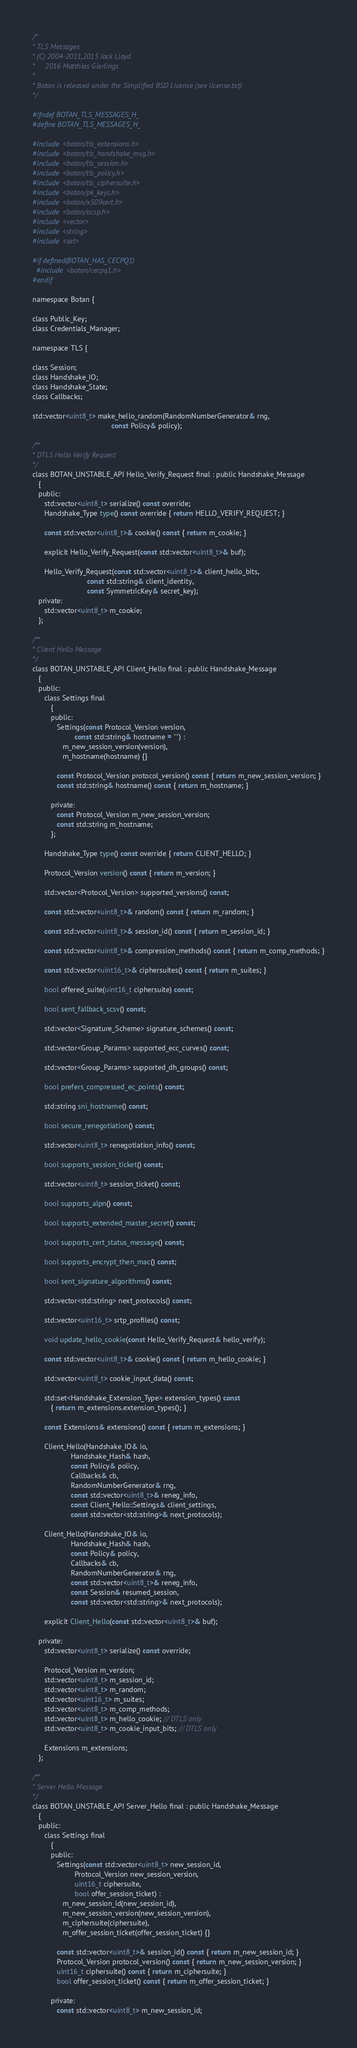<code> <loc_0><loc_0><loc_500><loc_500><_C_>/*
* TLS Messages
* (C) 2004-2011,2015 Jack Lloyd
*     2016 Matthias Gierlings
*
* Botan is released under the Simplified BSD License (see license.txt)
*/

#ifndef BOTAN_TLS_MESSAGES_H_
#define BOTAN_TLS_MESSAGES_H_

#include <botan/tls_extensions.h>
#include <botan/tls_handshake_msg.h>
#include <botan/tls_session.h>
#include <botan/tls_policy.h>
#include <botan/tls_ciphersuite.h>
#include <botan/pk_keys.h>
#include <botan/x509cert.h>
#include <botan/ocsp.h>
#include <vector>
#include <string>
#include <set>

#if defined(BOTAN_HAS_CECPQ1)
  #include <botan/cecpq1.h>
#endif

namespace Botan {

class Public_Key;
class Credentials_Manager;

namespace TLS {

class Session;
class Handshake_IO;
class Handshake_State;
class Callbacks;

std::vector<uint8_t> make_hello_random(RandomNumberGenerator& rng,
                                       const Policy& policy);

/**
* DTLS Hello Verify Request
*/
class BOTAN_UNSTABLE_API Hello_Verify_Request final : public Handshake_Message
   {
   public:
      std::vector<uint8_t> serialize() const override;
      Handshake_Type type() const override { return HELLO_VERIFY_REQUEST; }

      const std::vector<uint8_t>& cookie() const { return m_cookie; }

      explicit Hello_Verify_Request(const std::vector<uint8_t>& buf);

      Hello_Verify_Request(const std::vector<uint8_t>& client_hello_bits,
                           const std::string& client_identity,
                           const SymmetricKey& secret_key);
   private:
      std::vector<uint8_t> m_cookie;
   };

/**
* Client Hello Message
*/
class BOTAN_UNSTABLE_API Client_Hello final : public Handshake_Message
   {
   public:
      class Settings final
         {
         public:
            Settings(const Protocol_Version version,
                     const std::string& hostname = "") :
               m_new_session_version(version),
               m_hostname(hostname) {}

            const Protocol_Version protocol_version() const { return m_new_session_version; }
            const std::string& hostname() const { return m_hostname; }

         private:
            const Protocol_Version m_new_session_version;
            const std::string m_hostname;
         };

      Handshake_Type type() const override { return CLIENT_HELLO; }

      Protocol_Version version() const { return m_version; }

      std::vector<Protocol_Version> supported_versions() const;

      const std::vector<uint8_t>& random() const { return m_random; }

      const std::vector<uint8_t>& session_id() const { return m_session_id; }

      const std::vector<uint8_t>& compression_methods() const { return m_comp_methods; }

      const std::vector<uint16_t>& ciphersuites() const { return m_suites; }

      bool offered_suite(uint16_t ciphersuite) const;

      bool sent_fallback_scsv() const;

      std::vector<Signature_Scheme> signature_schemes() const;

      std::vector<Group_Params> supported_ecc_curves() const;

      std::vector<Group_Params> supported_dh_groups() const;

      bool prefers_compressed_ec_points() const;

      std::string sni_hostname() const;

      bool secure_renegotiation() const;

      std::vector<uint8_t> renegotiation_info() const;

      bool supports_session_ticket() const;

      std::vector<uint8_t> session_ticket() const;

      bool supports_alpn() const;

      bool supports_extended_master_secret() const;

      bool supports_cert_status_message() const;

      bool supports_encrypt_then_mac() const;

      bool sent_signature_algorithms() const;

      std::vector<std::string> next_protocols() const;

      std::vector<uint16_t> srtp_profiles() const;

      void update_hello_cookie(const Hello_Verify_Request& hello_verify);

      const std::vector<uint8_t>& cookie() const { return m_hello_cookie; }

      std::vector<uint8_t> cookie_input_data() const;

      std::set<Handshake_Extension_Type> extension_types() const
         { return m_extensions.extension_types(); }

      const Extensions& extensions() const { return m_extensions; }

      Client_Hello(Handshake_IO& io,
                   Handshake_Hash& hash,
                   const Policy& policy,
                   Callbacks& cb,
                   RandomNumberGenerator& rng,
                   const std::vector<uint8_t>& reneg_info,
                   const Client_Hello::Settings& client_settings,
                   const std::vector<std::string>& next_protocols);

      Client_Hello(Handshake_IO& io,
                   Handshake_Hash& hash,
                   const Policy& policy,
                   Callbacks& cb,
                   RandomNumberGenerator& rng,
                   const std::vector<uint8_t>& reneg_info,
                   const Session& resumed_session,
                   const std::vector<std::string>& next_protocols);

      explicit Client_Hello(const std::vector<uint8_t>& buf);

   private:
      std::vector<uint8_t> serialize() const override;

      Protocol_Version m_version;
      std::vector<uint8_t> m_session_id;
      std::vector<uint8_t> m_random;
      std::vector<uint16_t> m_suites;
      std::vector<uint8_t> m_comp_methods;
      std::vector<uint8_t> m_hello_cookie; // DTLS only
      std::vector<uint8_t> m_cookie_input_bits; // DTLS only

      Extensions m_extensions;
   };

/**
* Server Hello Message
*/
class BOTAN_UNSTABLE_API Server_Hello final : public Handshake_Message
   {
   public:
      class Settings final
         {
         public:
            Settings(const std::vector<uint8_t> new_session_id,
                     Protocol_Version new_session_version,
                     uint16_t ciphersuite,
                     bool offer_session_ticket) :
               m_new_session_id(new_session_id),
               m_new_session_version(new_session_version),
               m_ciphersuite(ciphersuite),
               m_offer_session_ticket(offer_session_ticket) {}

            const std::vector<uint8_t>& session_id() const { return m_new_session_id; }
            Protocol_Version protocol_version() const { return m_new_session_version; }
            uint16_t ciphersuite() const { return m_ciphersuite; }
            bool offer_session_ticket() const { return m_offer_session_ticket; }

         private:
            const std::vector<uint8_t> m_new_session_id;</code> 